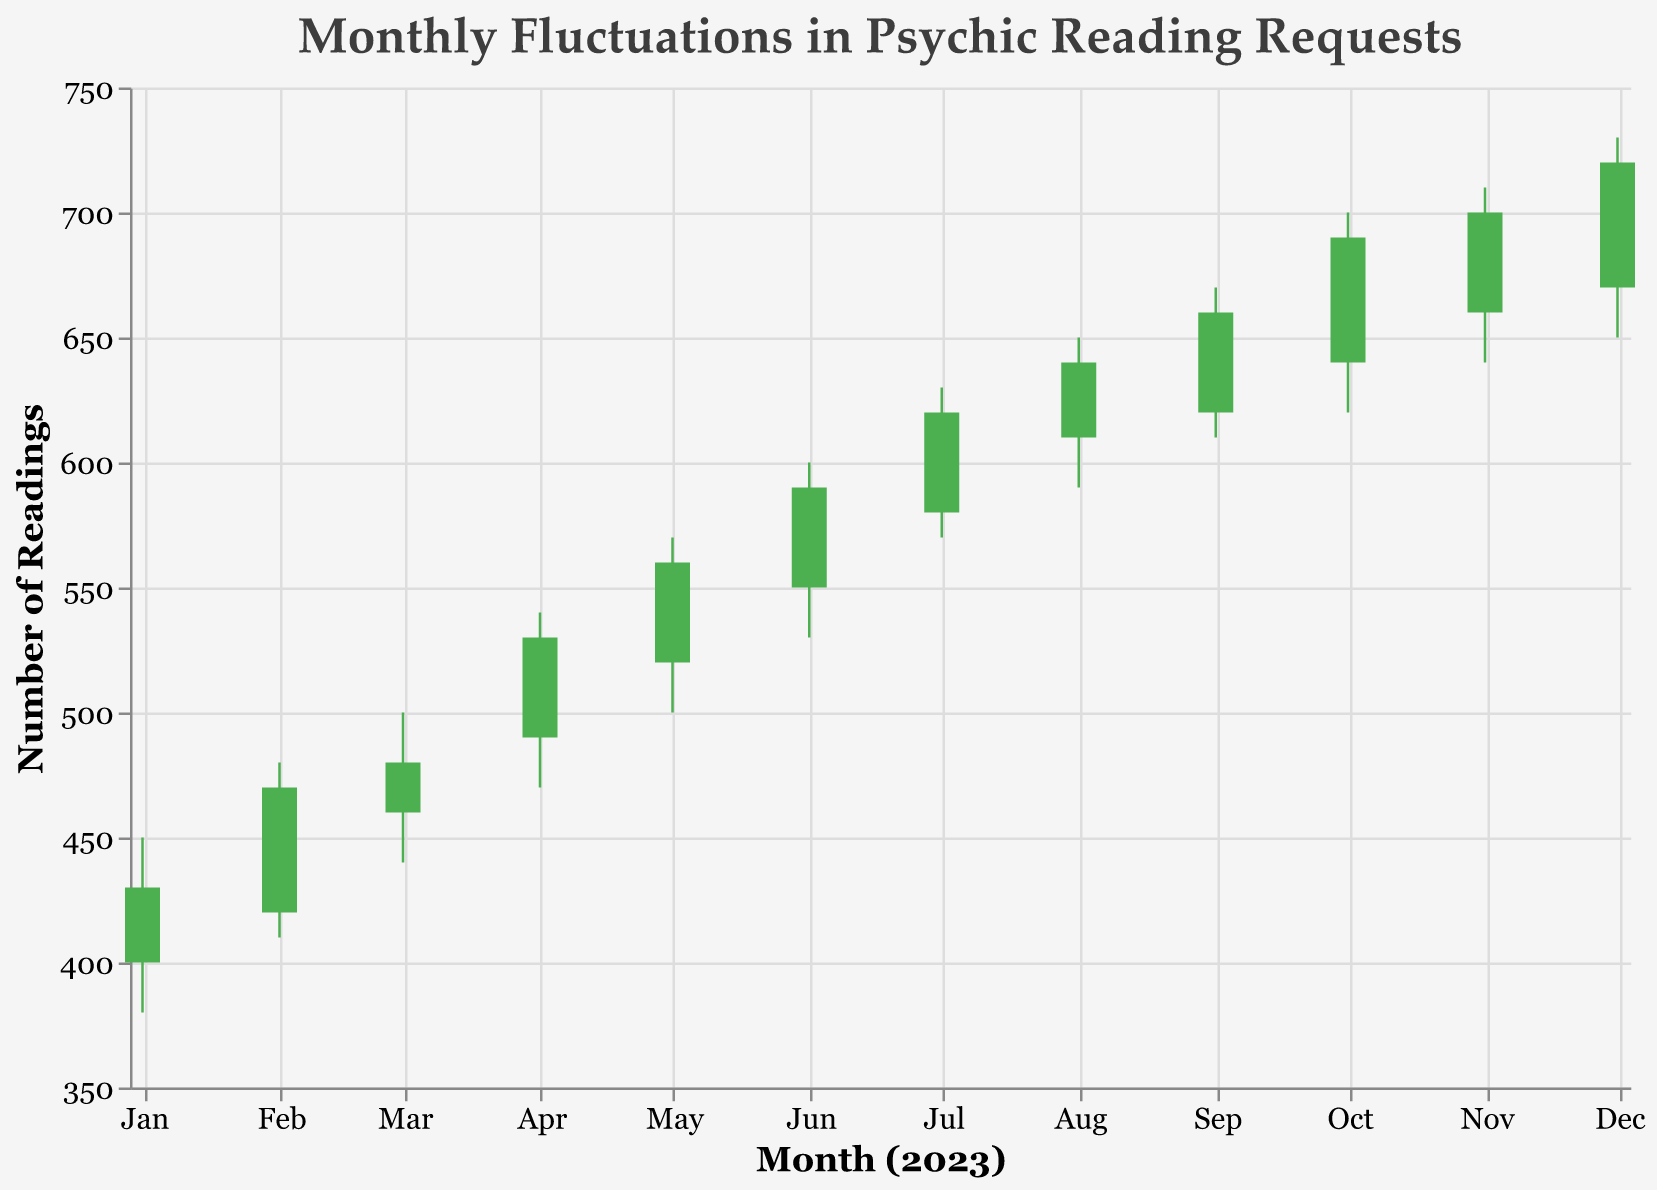What is the title of the figure? The title of the chart is displayed at the top and reads "Monthly Fluctuations in Psychic Reading Requests".
Answer: Monthly Fluctuations in Psychic Reading Requests What can you infer about the trend of psychic reading requests from January to December 2023? To infer the trend, observe the candlestick movements across the months. Notably, the 'Open' and 'Close' values generally increase from January to December, indicating a rising trend in requests.
Answer: Increasing trend In which month did psychic reading requests reach their highest high? To determine the month with the highest high, look at the peak of the 'High' values across the monthly candlesticks. The 'High' value is the highest in December 2023.
Answer: December 2023 Which month had the largest difference between the highest and lowest number of psychic reading requests? Calculate the difference between 'High' and 'Low' for each month. The largest difference appears in October 2023 with a range of (700 - 620) = 80.
Answer: October 2023 In which months did the number of psychic reading requests close higher than the opening value? For a month where 'Close' is higher than 'Open', the bar within the candlestick will be green. The months where this condition is met are January, February, March, April, May, June, July, August, September, October, November, and December.
Answer: Every month Compare the number of positive outcomes in July and December 2023. Which month had more positive outcomes? By comparing the 'OutcomesPositive' values, July had 510 positive outcomes, while December had 600. Therefore, December had more positive outcomes.
Answer: December 2023 What is the average closing value of psychic reading requests from January to June 2023? Calculate the sum of the closing values from January to June (430 + 470 + 480 + 530 + 560 + 590) and divide by 6. The sum is 3060, so the average is 3060 / 6 = 510.
Answer: 510 Which month experienced the highest number of negative outcomes? Compare the 'OutcomesNegative' values for each month. The highest number of negative outcomes is in August and September 2023, both with 140 negative outcomes.
Answer: August and September 2023 What is the difference in the highest number of readings between January and December 2023? Calculate the difference between the 'High' values of January (450) and December (730). The difference is 730 - 450 = 280.
Answer: 280 